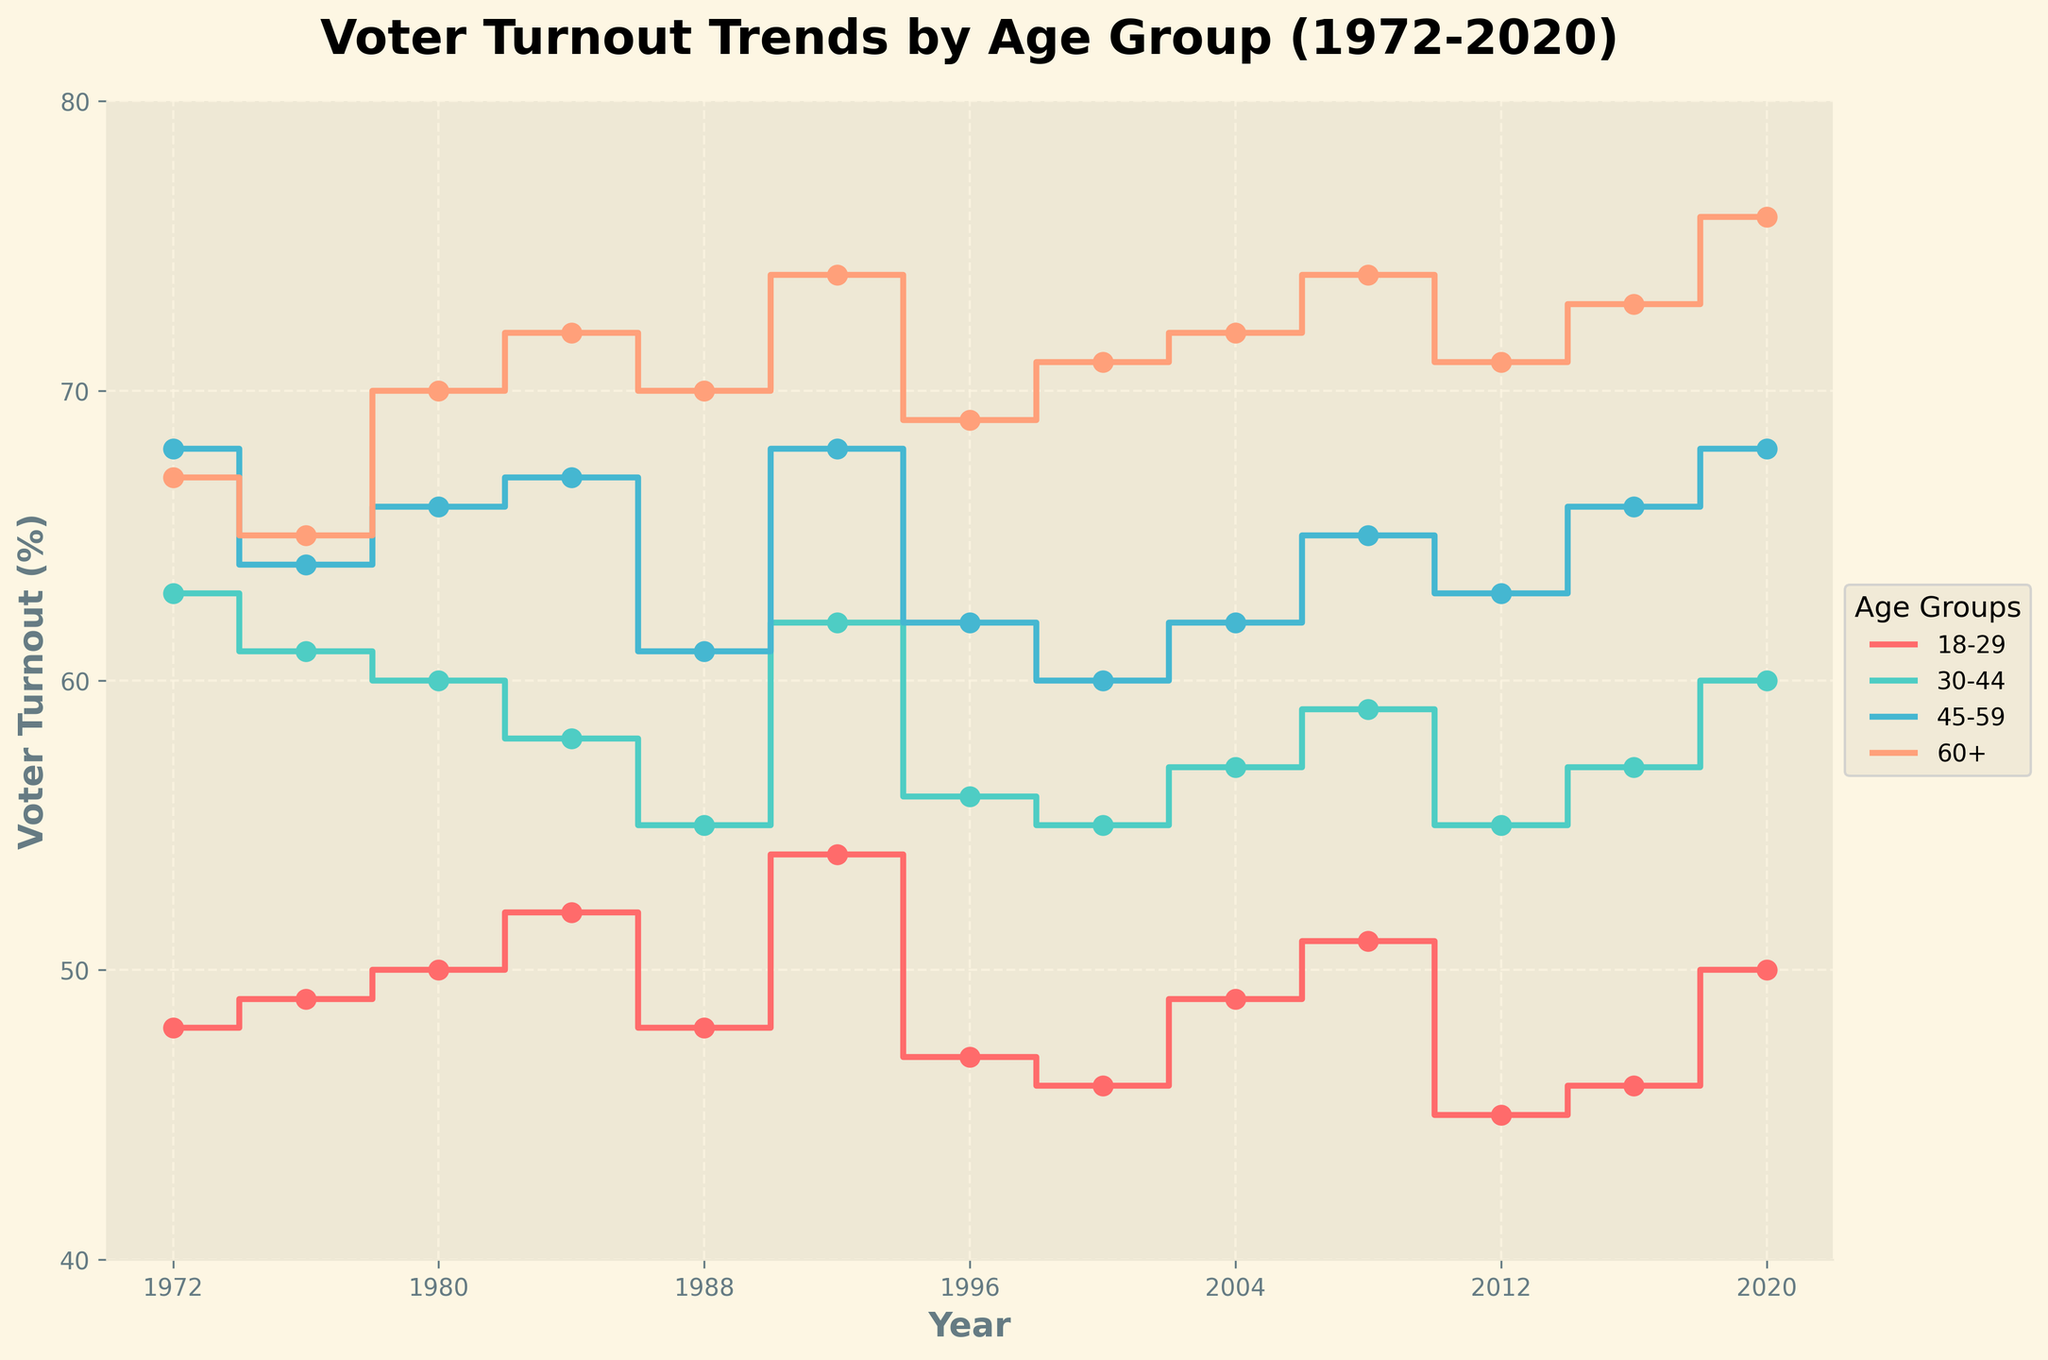what is the title of the figure? The title is written at the top of the figure. It reads: 'Voter Turnout Trends by Age Group (1972-2020)'.
Answer: Voter Turnout Trends by Age Group (1972-2020) How many age groups are displayed in the figure? By examining the legend on the right side of the figure, you can see there are four age groups: '18-29', '30-44', '45-59', and '60+'.
Answer: 4 What was the voter turnout for the '30-44' age group in 1988? Find the segment of the stairs plot corresponding to the '30-44' age group and trace the value for the year 1988, which is at a tick on the x-axis. The value reads 55%.
Answer: 55% In what year did the '18-29' age group have the highest voter turnout according to the plot? Look through the '18-29' age group's trajectory on the stair plot and find the highest point, which occurs in 1992 at 54%.
Answer: 1992 What is the difference in voter turnout between the '45-59' and '60+' age groups in 2000? Locate the values for the '45-59' and '60+' age groups in the year 2000. The voter turnout for '45-59' is 60%, and for '60+' it is 71%. Calculate the difference: 71% - 60% = 11%.
Answer: 11% Which age group had the most consistent (least variable) voter turnout over the years? By observing the stair plot lines' variance, the '60+' age group shows the least fluctuation, indicating it had the most consistent voter turnout.
Answer: 60+ How has the voter turnout trend for the '18-29' age group varied from 1972 to 2020? Follow the '18-29' age group line from 1972 to 2020. The trend shows some ups and downs, with notable peaks in 1992 and a slight increase again in 2020, starting at 48%, peaking at 54% in 1992, and reaching 50% in 2020.
Answer: Fluctuated with peaks in 1992 and 2020 Compare the voter turnout for '60+' age group in the first year (1972) and the last year (2020). How much has it increased? Trace the '60+' voter turnout line to the year 1972, which is at 67%, and then in 2020, which is at 76%. Calculate the increase: 76% - 67% = 9%.
Answer: 9% Which age group had the lowest voter turnout in 2012 and what is the corresponding percentage? Look for the lowest point on the stair plot for the year 2012. The '18-29' age group has the lowest voter turnout at 45%.
Answer: 18-29, 45% Has any age group shown a general decline in voter turnout over the last 50 years? Examine each age group's trend line from 1972 to 2020. The '30-44' group shows a general decline, starting at a higher percentage and trending downwards over time, though with some fluctuations.
Answer: 30-44 